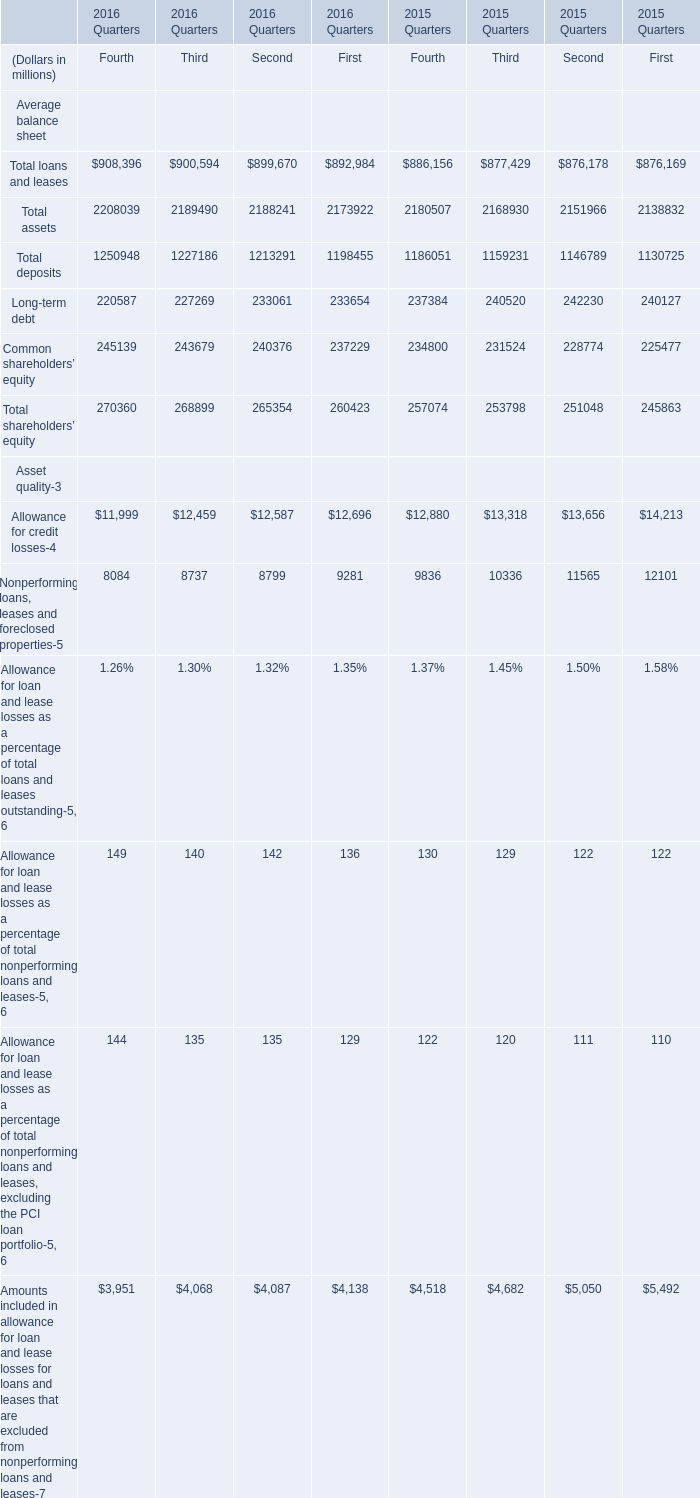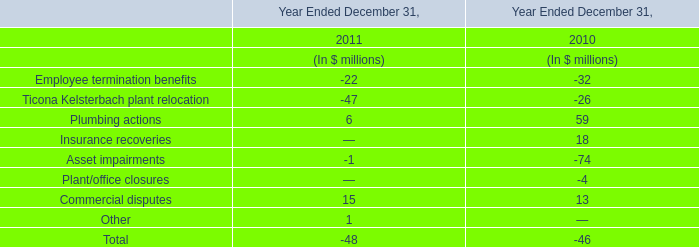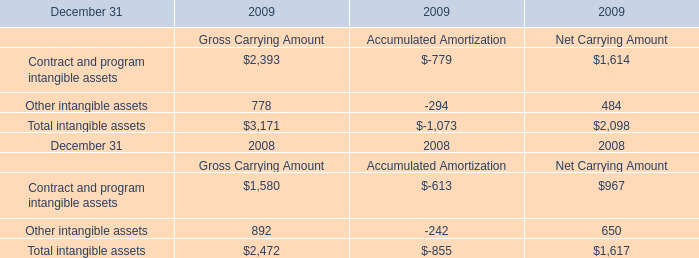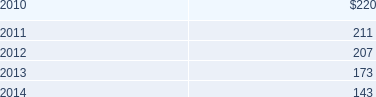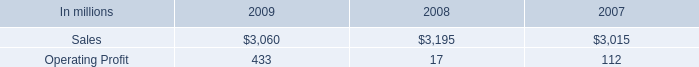What is the average amount of Contract and program intangible assets of 2009 Net Carrying Amount, and Allowance for credit losses Asset quality of 2015 Quarters First ? 
Computations: ((1614.0 + 14213.0) / 2)
Answer: 7913.5. 